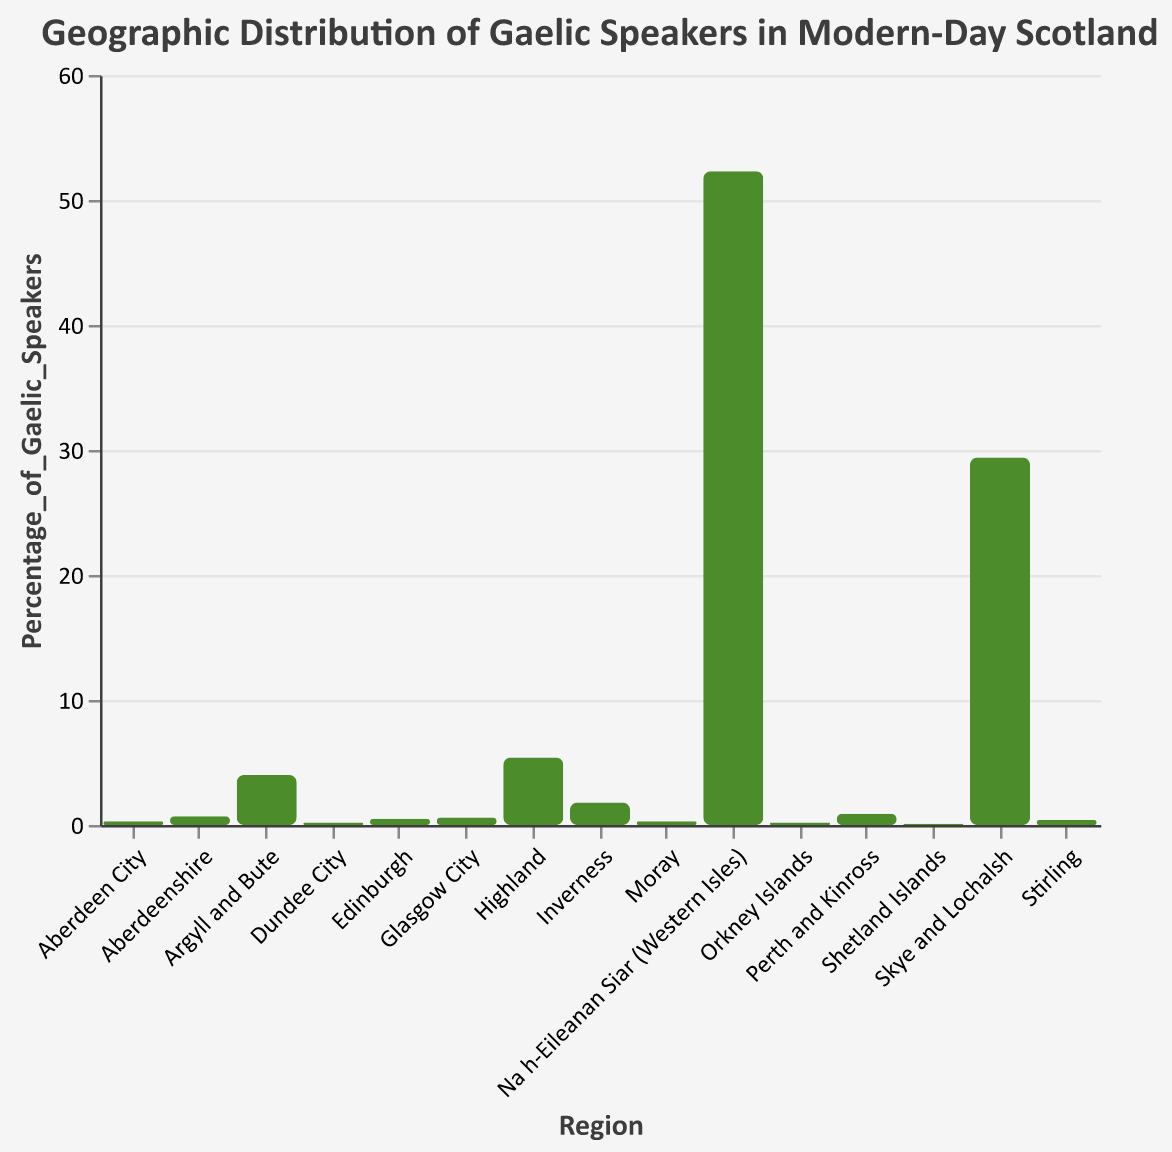What is the title of the figure? The title of the figure is usually located at the top and specifies the subject of the visualized data. Here, the title reads "Geographic Distribution of Gaelic Speakers in Modern-Day Scotland."
Answer: Geographic Distribution of Gaelic Speakers in Modern-Day Scotland Which region has the highest percentage of Gaelic speakers? Looking at the bar heights, Na h-Eileanan Siar (Western Isles) has the tallest bar, implying it has the highest percentage. This is confirmed by the tooltip or y-axis value of 52.3%.
Answer: Na h-Eileanan Siar (Western Isles) What is the percentage of Gaelic speakers in Edinburgh? Find the bar corresponding to “Edinburgh” and check its height relative to the y-axis or use the tooltip, which indicates 0.5%.
Answer: 0.5% How many regions have a percentage of Gaelic speakers greater than 1%? Identify and count the bars that exceed the 1% mark on the y-axis: Na h-Eileanan Siar (Western Isles), Highland, Argyll and Bute, Skye and Lochalsh, and Inverness. There are 5 such bars.
Answer: 5 What is the difference in percentage of Gaelic speakers between the regions with the highest and the second-highest percentages? Na h-Eileanan Siar (Western Isles) has 52.3%, and Skye and Lochalsh has 29.4%. The difference is 52.3% - 29.4%.
Answer: 22.9% Which region has the lowest percentage of Gaelic speakers, and what is that percentage? The shortest bar is for the Shetland Islands, as indicated by the height and the 0.1% value on the tooltip or y-axis.
Answer: Shetland Islands, 0.1% How does the percentage of Gaelic speakers in Glasgow City compare to that in Perth and Kinross? Compare the heights of the bars for Glasgow City (0.6%) and Perth and Kinross (0.9%). Glasgow City has a lower percentage than Perth and Kinross.
Answer: Glasgow City has a lower percentage What is the average percentage of Gaelic speakers across all regions? Sum the percentages for all regions and divide by the number of regions: (52.3 + 5.4 + 4.0 + 0.9 + 0.7 + 0.6 + 0.5 + 1.8 + 29.4 + 0.2 + 0.1 + 0.4 + 0.3 + 0.2 + 0.3) / 15 = 6.71
Answer: 6.71 Which three regions have the highest percentages of Gaelic speakers, and what are those percentages? Identify the three tallest bars: Na h-Eileanan Siar (Western Isles) with 52.3%, Skye and Lochalsh with 29.4%, and Highland with 5.4%.
Answer: Na h-Eileanan Siar (Western Isles) - 52.3%, Skye and Lochalsh - 29.4%, Highland - 5.4% Are the regions with higher percentages of Gaelic speakers primarily rural or urban? Observing the regions with high percentages, they are predominantly rural areas like Na h-Eileanan Siar (Western Isles), Skye and Lochalsh, and Highland.
Answer: Primarily rural 